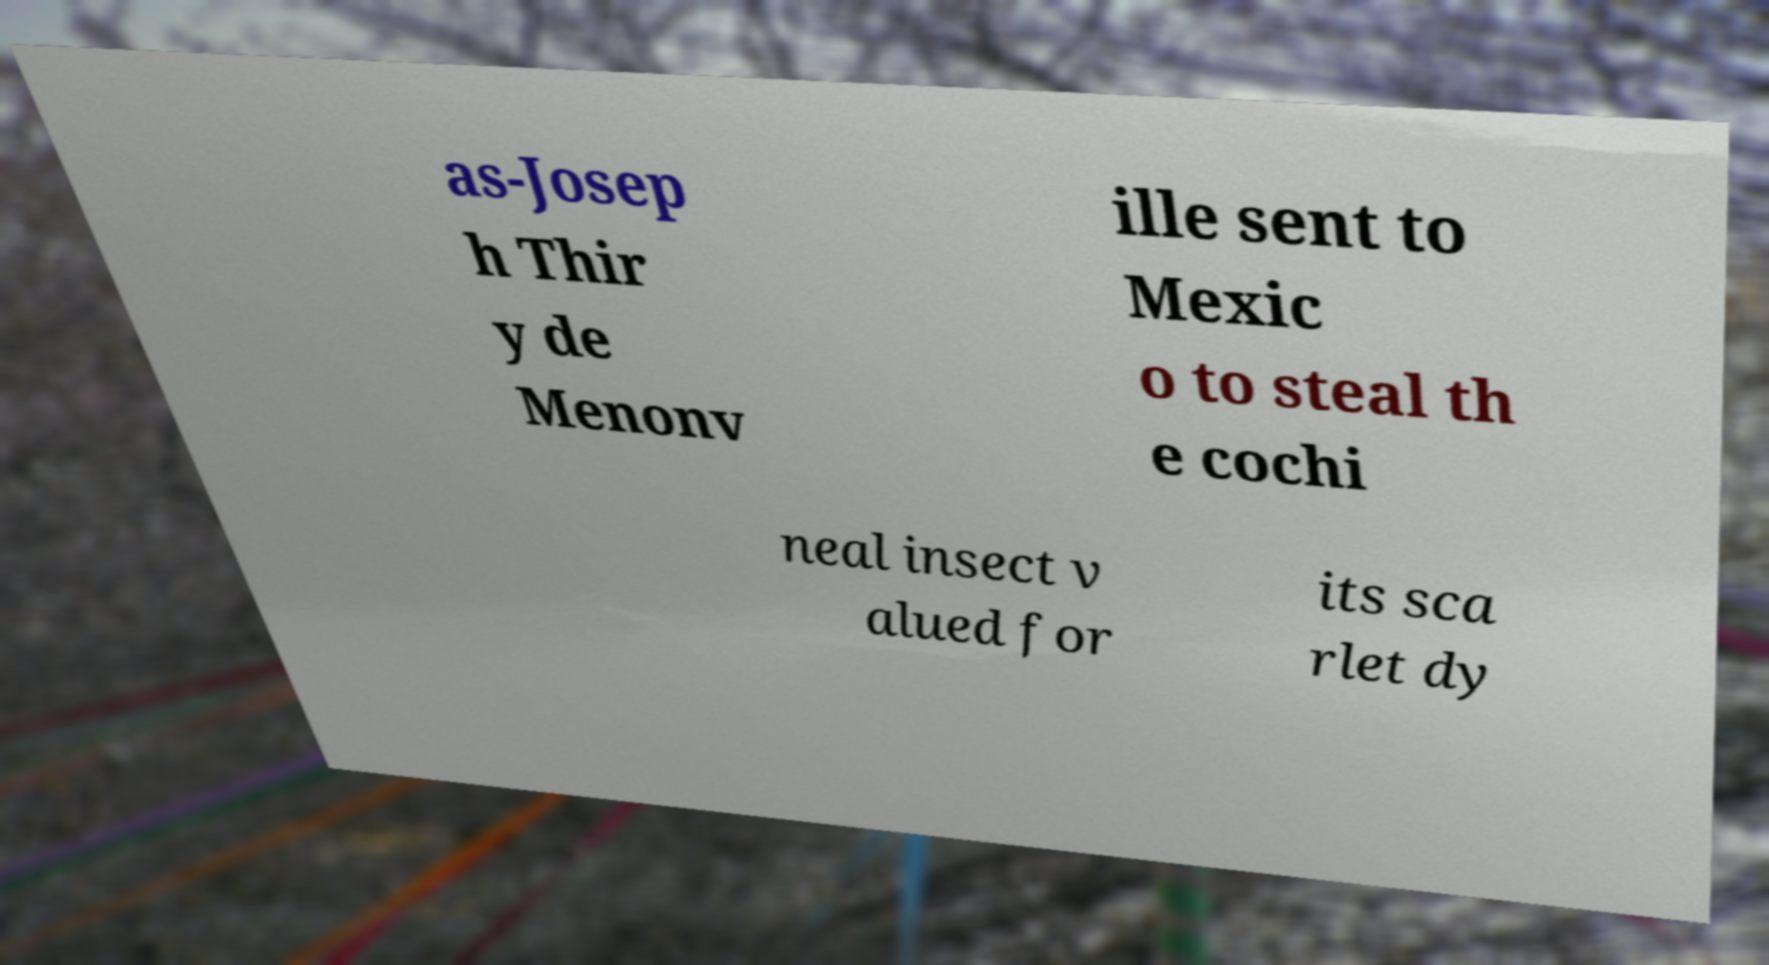Please identify and transcribe the text found in this image. as-Josep h Thir y de Menonv ille sent to Mexic o to steal th e cochi neal insect v alued for its sca rlet dy 